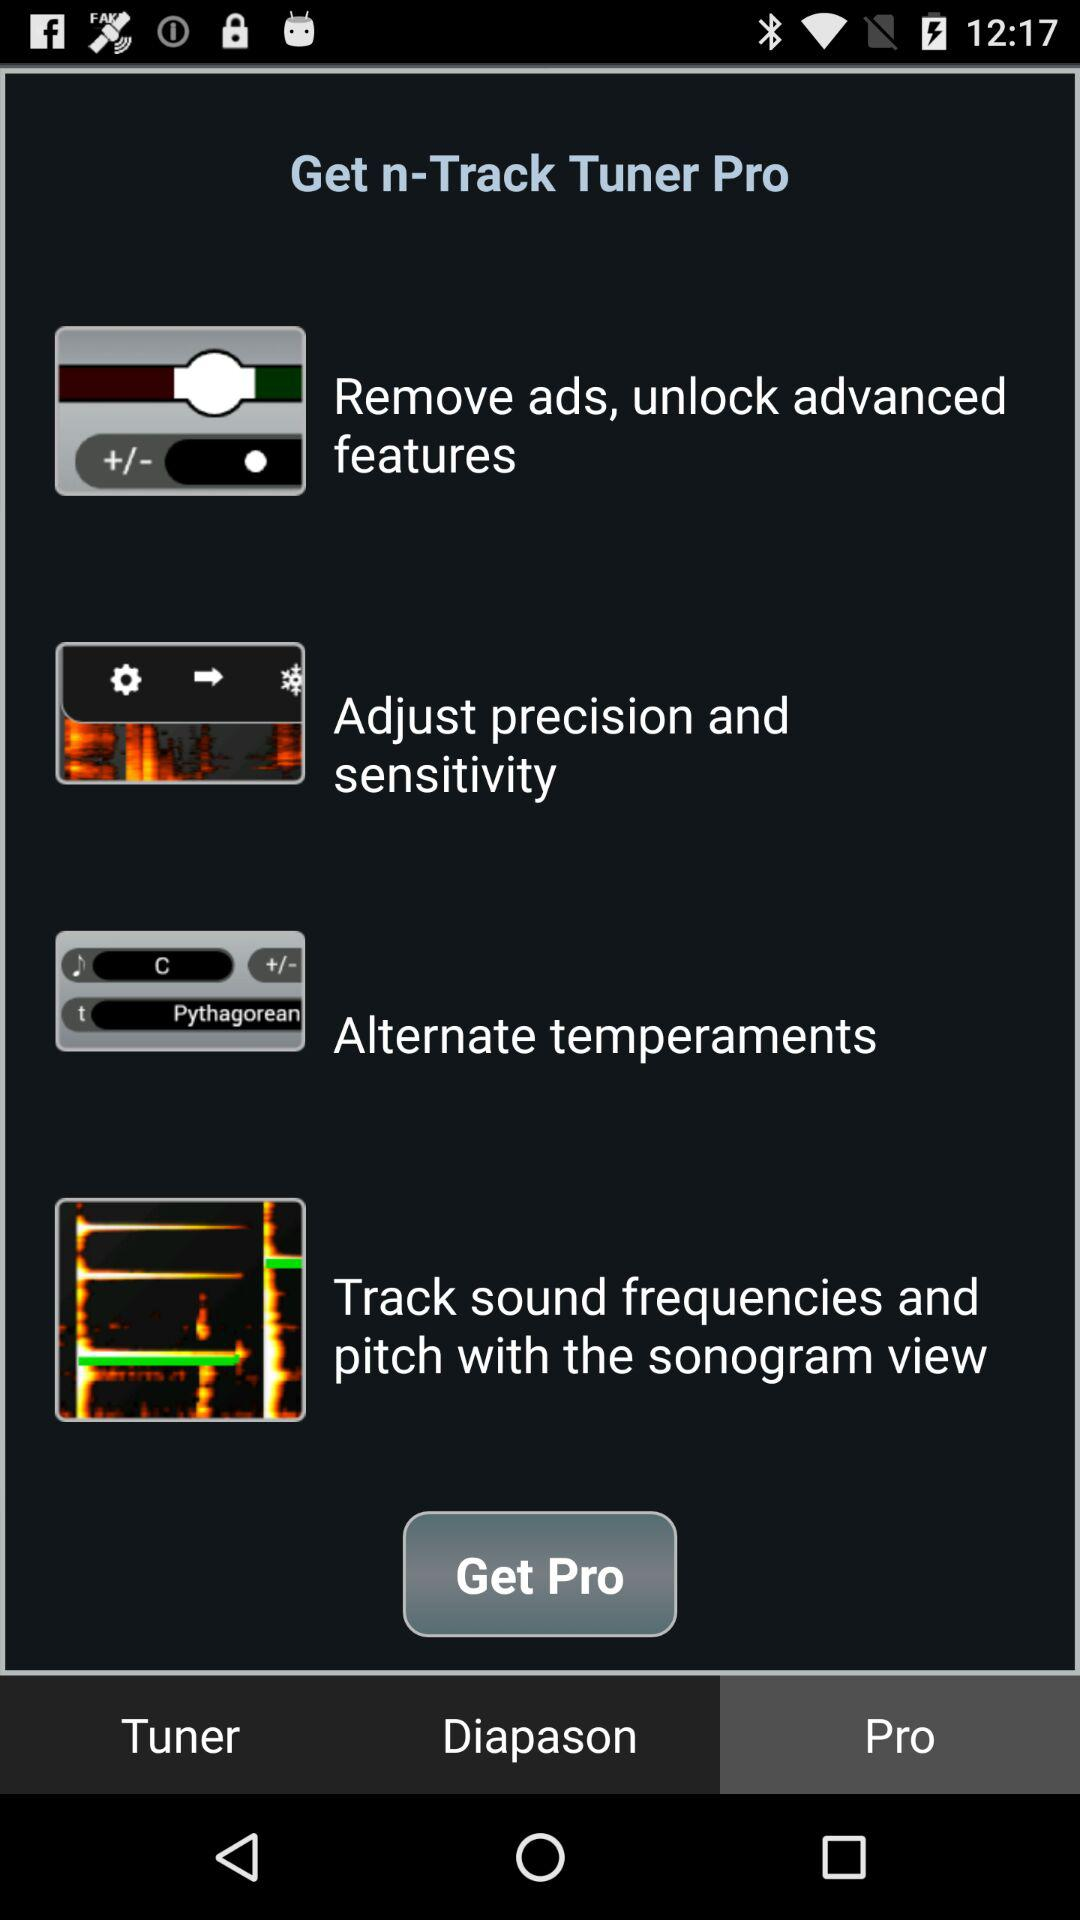What is the name of the application? The name of the application is "n-Track Tuner". 